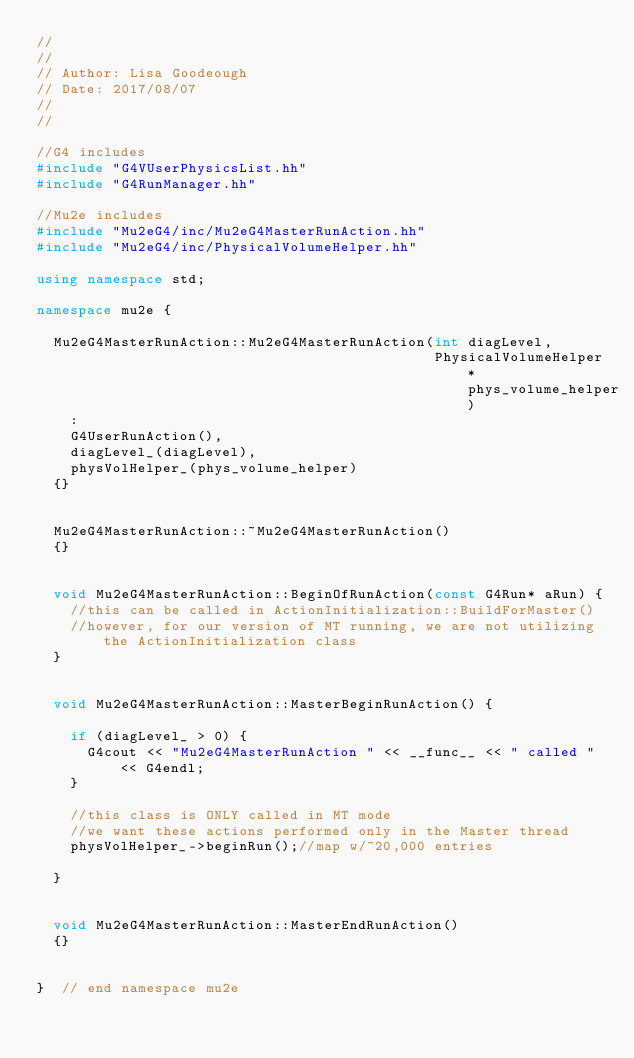<code> <loc_0><loc_0><loc_500><loc_500><_C++_>//
//
// Author: Lisa Goodeough
// Date: 2017/08/07
//
//

//G4 includes
#include "G4VUserPhysicsList.hh"
#include "G4RunManager.hh"

//Mu2e includes
#include "Mu2eG4/inc/Mu2eG4MasterRunAction.hh"
#include "Mu2eG4/inc/PhysicalVolumeHelper.hh"

using namespace std;

namespace mu2e {

  Mu2eG4MasterRunAction::Mu2eG4MasterRunAction(int diagLevel,
                                               PhysicalVolumeHelper* phys_volume_helper)
    :
    G4UserRunAction(),
    diagLevel_(diagLevel),
    physVolHelper_(phys_volume_helper)
  {}


  Mu2eG4MasterRunAction::~Mu2eG4MasterRunAction()
  {}


  void Mu2eG4MasterRunAction::BeginOfRunAction(const G4Run* aRun) {
    //this can be called in ActionInitialization::BuildForMaster()
    //however, for our version of MT running, we are not utilizing the ActionInitialization class
  }


  void Mu2eG4MasterRunAction::MasterBeginRunAction() {

    if (diagLevel_ > 0) {
      G4cout << "Mu2eG4MasterRunAction " << __func__ << " called " << G4endl;
    }

    //this class is ONLY called in MT mode
    //we want these actions performed only in the Master thread
    physVolHelper_->beginRun();//map w/~20,000 entries

  }


  void Mu2eG4MasterRunAction::MasterEndRunAction()
  {}


}  // end namespace mu2e
</code> 